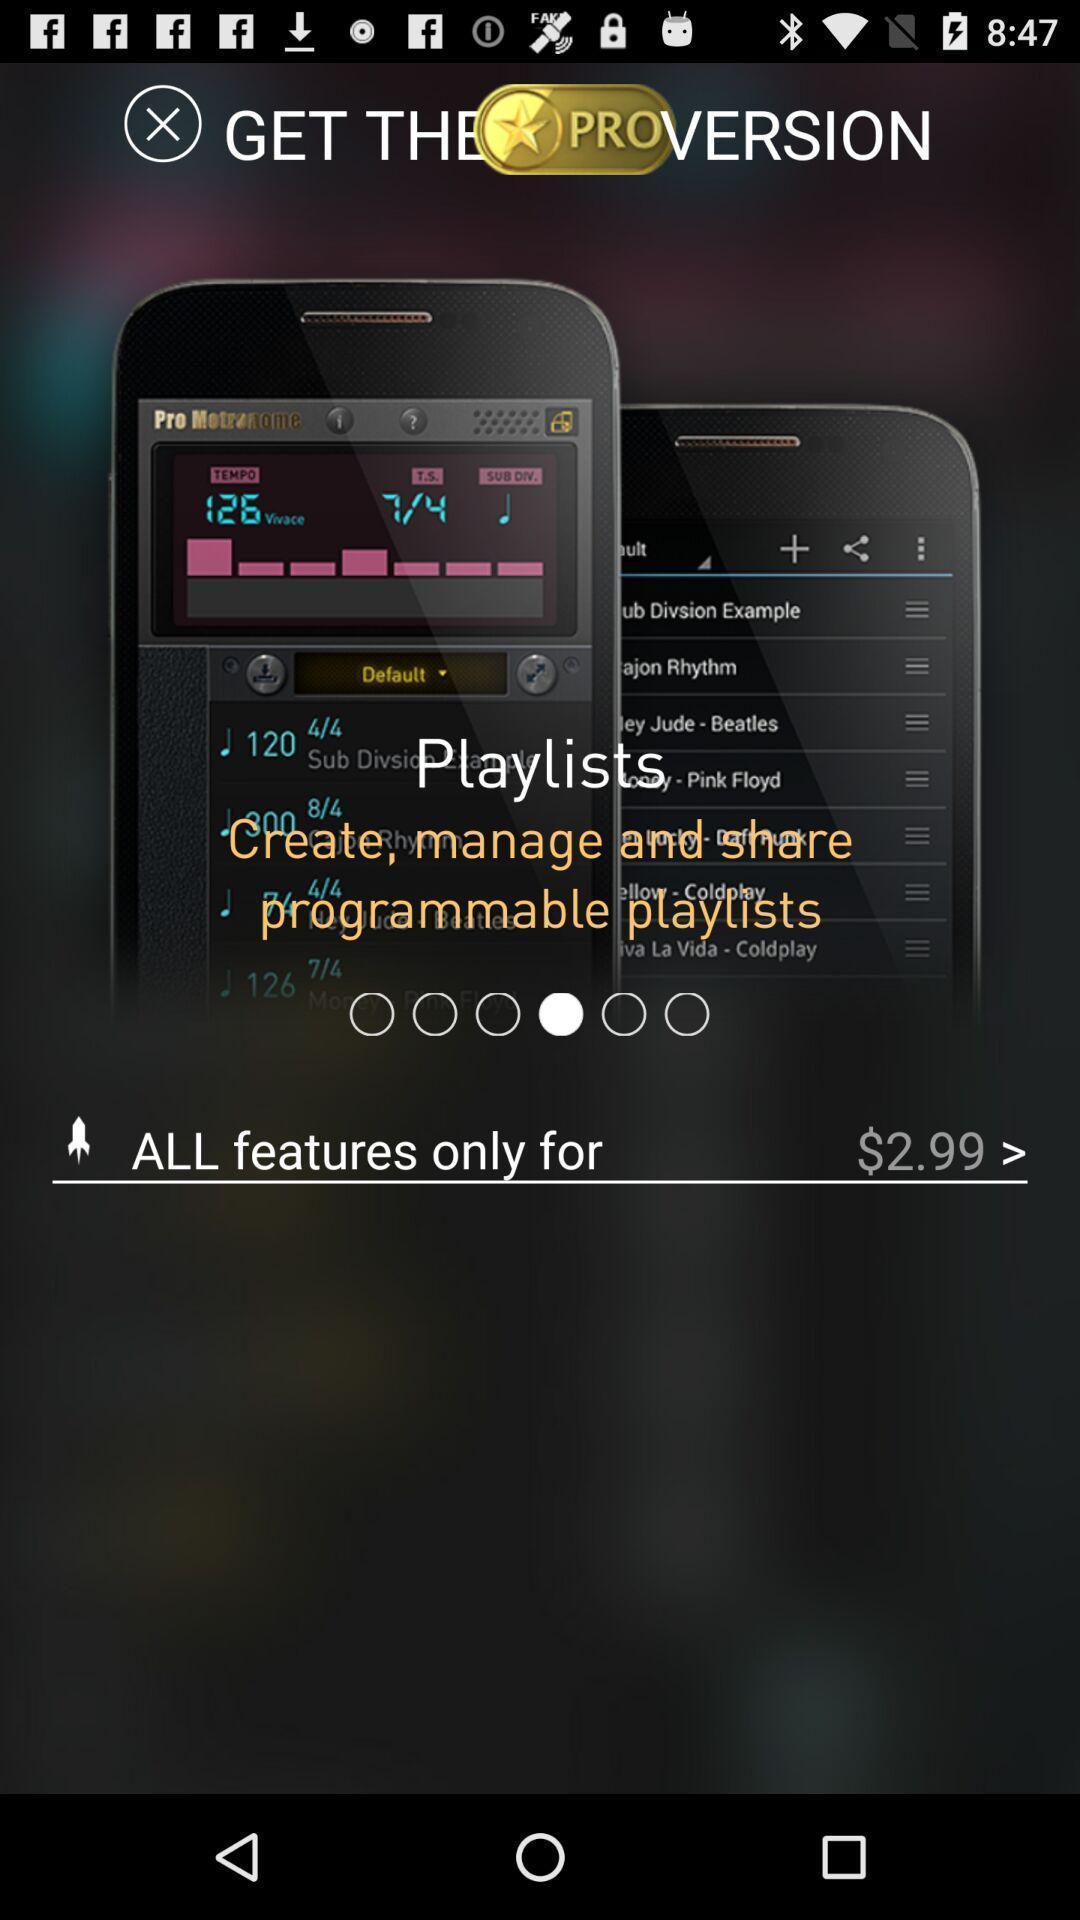Provide a description of this screenshot. Screen showing all features required. 